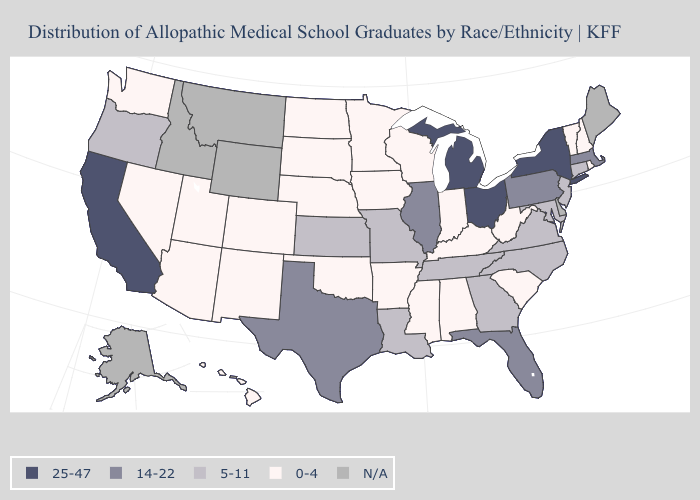Does Michigan have the lowest value in the USA?
Write a very short answer. No. Does South Dakota have the highest value in the MidWest?
Short answer required. No. What is the value of Rhode Island?
Quick response, please. 0-4. Which states have the highest value in the USA?
Concise answer only. California, Michigan, New York, Ohio. Name the states that have a value in the range 0-4?
Be succinct. Alabama, Arizona, Arkansas, Colorado, Hawaii, Indiana, Iowa, Kentucky, Minnesota, Mississippi, Nebraska, Nevada, New Hampshire, New Mexico, North Dakota, Oklahoma, Rhode Island, South Carolina, South Dakota, Utah, Vermont, Washington, West Virginia, Wisconsin. Which states hav the highest value in the MidWest?
Keep it brief. Michigan, Ohio. Does New Hampshire have the lowest value in the Northeast?
Concise answer only. Yes. What is the value of Mississippi?
Short answer required. 0-4. Name the states that have a value in the range 25-47?
Be succinct. California, Michigan, New York, Ohio. Among the states that border Idaho , which have the lowest value?
Answer briefly. Nevada, Utah, Washington. Does Utah have the highest value in the West?
Quick response, please. No. Name the states that have a value in the range 0-4?
Quick response, please. Alabama, Arizona, Arkansas, Colorado, Hawaii, Indiana, Iowa, Kentucky, Minnesota, Mississippi, Nebraska, Nevada, New Hampshire, New Mexico, North Dakota, Oklahoma, Rhode Island, South Carolina, South Dakota, Utah, Vermont, Washington, West Virginia, Wisconsin. What is the value of Washington?
Give a very brief answer. 0-4. What is the value of Kentucky?
Short answer required. 0-4. Name the states that have a value in the range 25-47?
Write a very short answer. California, Michigan, New York, Ohio. 